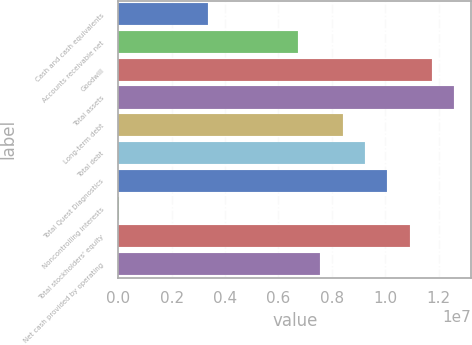<chart> <loc_0><loc_0><loc_500><loc_500><bar_chart><fcel>Cash and cash equivalents<fcel>Accounts receivable net<fcel>Goodwill<fcel>Total assets<fcel>Long-term debt<fcel>Total debt<fcel>Total Quest Diagnostics<fcel>Noncontrolling interests<fcel>Total stockholders' equity<fcel>Net cash provided by operating<nl><fcel>3.37367e+06<fcel>6.72711e+06<fcel>1.17573e+07<fcel>1.25956e+07<fcel>8.40383e+06<fcel>9.24219e+06<fcel>1.00805e+07<fcel>20238<fcel>1.09189e+07<fcel>7.56547e+06<nl></chart> 